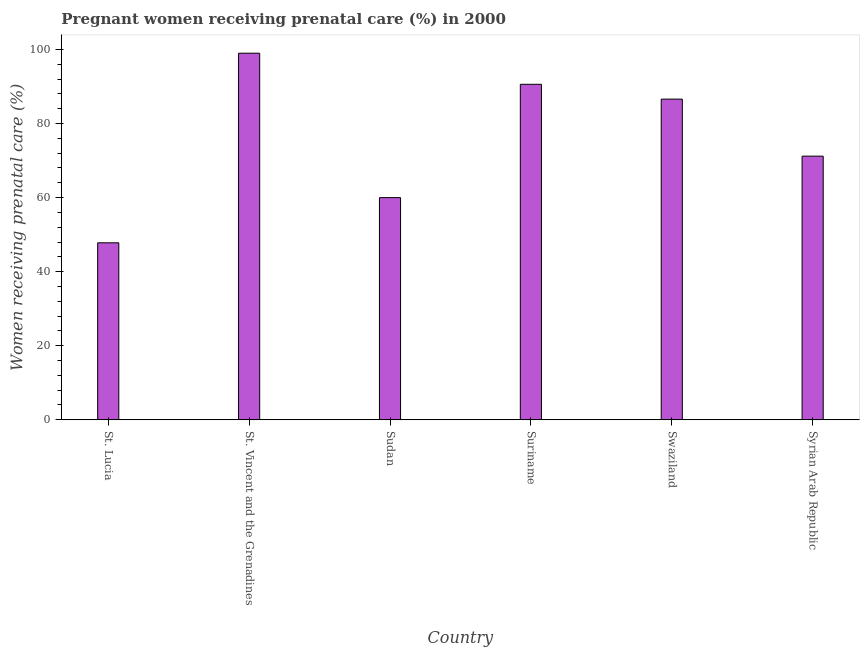Does the graph contain any zero values?
Your answer should be very brief. No. Does the graph contain grids?
Make the answer very short. No. What is the title of the graph?
Your answer should be compact. Pregnant women receiving prenatal care (%) in 2000. What is the label or title of the X-axis?
Offer a terse response. Country. What is the label or title of the Y-axis?
Provide a short and direct response. Women receiving prenatal care (%). Across all countries, what is the maximum percentage of pregnant women receiving prenatal care?
Your answer should be very brief. 99. Across all countries, what is the minimum percentage of pregnant women receiving prenatal care?
Keep it short and to the point. 47.8. In which country was the percentage of pregnant women receiving prenatal care maximum?
Give a very brief answer. St. Vincent and the Grenadines. In which country was the percentage of pregnant women receiving prenatal care minimum?
Your answer should be very brief. St. Lucia. What is the sum of the percentage of pregnant women receiving prenatal care?
Offer a very short reply. 455.2. What is the difference between the percentage of pregnant women receiving prenatal care in St. Lucia and Suriname?
Your response must be concise. -42.8. What is the average percentage of pregnant women receiving prenatal care per country?
Make the answer very short. 75.87. What is the median percentage of pregnant women receiving prenatal care?
Give a very brief answer. 78.9. In how many countries, is the percentage of pregnant women receiving prenatal care greater than 56 %?
Ensure brevity in your answer.  5. What is the ratio of the percentage of pregnant women receiving prenatal care in St. Vincent and the Grenadines to that in Swaziland?
Provide a succinct answer. 1.14. Is the difference between the percentage of pregnant women receiving prenatal care in St. Vincent and the Grenadines and Swaziland greater than the difference between any two countries?
Your response must be concise. No. What is the difference between the highest and the lowest percentage of pregnant women receiving prenatal care?
Provide a short and direct response. 51.2. In how many countries, is the percentage of pregnant women receiving prenatal care greater than the average percentage of pregnant women receiving prenatal care taken over all countries?
Make the answer very short. 3. How many countries are there in the graph?
Your response must be concise. 6. What is the difference between two consecutive major ticks on the Y-axis?
Offer a very short reply. 20. What is the Women receiving prenatal care (%) in St. Lucia?
Ensure brevity in your answer.  47.8. What is the Women receiving prenatal care (%) in Sudan?
Make the answer very short. 60. What is the Women receiving prenatal care (%) in Suriname?
Your answer should be very brief. 90.6. What is the Women receiving prenatal care (%) of Swaziland?
Make the answer very short. 86.6. What is the Women receiving prenatal care (%) of Syrian Arab Republic?
Your response must be concise. 71.2. What is the difference between the Women receiving prenatal care (%) in St. Lucia and St. Vincent and the Grenadines?
Keep it short and to the point. -51.2. What is the difference between the Women receiving prenatal care (%) in St. Lucia and Suriname?
Ensure brevity in your answer.  -42.8. What is the difference between the Women receiving prenatal care (%) in St. Lucia and Swaziland?
Ensure brevity in your answer.  -38.8. What is the difference between the Women receiving prenatal care (%) in St. Lucia and Syrian Arab Republic?
Your answer should be very brief. -23.4. What is the difference between the Women receiving prenatal care (%) in St. Vincent and the Grenadines and Syrian Arab Republic?
Offer a terse response. 27.8. What is the difference between the Women receiving prenatal care (%) in Sudan and Suriname?
Give a very brief answer. -30.6. What is the difference between the Women receiving prenatal care (%) in Sudan and Swaziland?
Ensure brevity in your answer.  -26.6. What is the difference between the Women receiving prenatal care (%) in Suriname and Syrian Arab Republic?
Provide a short and direct response. 19.4. What is the difference between the Women receiving prenatal care (%) in Swaziland and Syrian Arab Republic?
Offer a very short reply. 15.4. What is the ratio of the Women receiving prenatal care (%) in St. Lucia to that in St. Vincent and the Grenadines?
Offer a terse response. 0.48. What is the ratio of the Women receiving prenatal care (%) in St. Lucia to that in Sudan?
Offer a very short reply. 0.8. What is the ratio of the Women receiving prenatal care (%) in St. Lucia to that in Suriname?
Your response must be concise. 0.53. What is the ratio of the Women receiving prenatal care (%) in St. Lucia to that in Swaziland?
Your answer should be compact. 0.55. What is the ratio of the Women receiving prenatal care (%) in St. Lucia to that in Syrian Arab Republic?
Your answer should be compact. 0.67. What is the ratio of the Women receiving prenatal care (%) in St. Vincent and the Grenadines to that in Sudan?
Your response must be concise. 1.65. What is the ratio of the Women receiving prenatal care (%) in St. Vincent and the Grenadines to that in Suriname?
Provide a short and direct response. 1.09. What is the ratio of the Women receiving prenatal care (%) in St. Vincent and the Grenadines to that in Swaziland?
Keep it short and to the point. 1.14. What is the ratio of the Women receiving prenatal care (%) in St. Vincent and the Grenadines to that in Syrian Arab Republic?
Ensure brevity in your answer.  1.39. What is the ratio of the Women receiving prenatal care (%) in Sudan to that in Suriname?
Give a very brief answer. 0.66. What is the ratio of the Women receiving prenatal care (%) in Sudan to that in Swaziland?
Your answer should be compact. 0.69. What is the ratio of the Women receiving prenatal care (%) in Sudan to that in Syrian Arab Republic?
Provide a short and direct response. 0.84. What is the ratio of the Women receiving prenatal care (%) in Suriname to that in Swaziland?
Your answer should be very brief. 1.05. What is the ratio of the Women receiving prenatal care (%) in Suriname to that in Syrian Arab Republic?
Make the answer very short. 1.27. What is the ratio of the Women receiving prenatal care (%) in Swaziland to that in Syrian Arab Republic?
Offer a terse response. 1.22. 